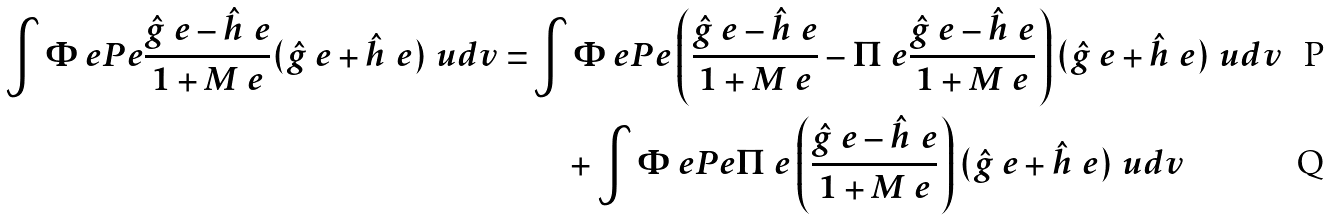<formula> <loc_0><loc_0><loc_500><loc_500>\int \Phi _ { \ } e P _ { \ } e \frac { \hat { g } _ { \ } e - \hat { h } _ { \ } e } { 1 + M _ { \ } e } ( \hat { g } _ { \ } e + \hat { h } _ { \ } e ) \ u d v = & \int \Phi _ { \ } e P _ { \ } e \left ( \frac { \hat { g } _ { \ } e - \hat { h } _ { \ } e } { 1 + M _ { \ } e } - \Pi _ { \ } e \frac { \hat { g } _ { \ } e - \hat { h } _ { \ } e } { 1 + M _ { \ } e } \right ) ( \hat { g } _ { \ } e + \hat { h } _ { \ } e ) \ u d v \\ & \quad + \int \Phi _ { \ } e P _ { \ } e \Pi _ { \ } e \left ( \frac { \hat { g } _ { \ } e - \hat { h } _ { \ } e } { 1 + M _ { \ } e } \right ) ( \hat { g } _ { \ } e + \hat { h } _ { \ } e ) \ u d v</formula> 